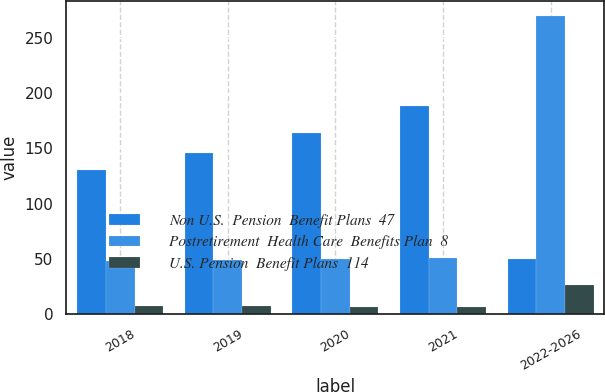Convert chart to OTSL. <chart><loc_0><loc_0><loc_500><loc_500><stacked_bar_chart><ecel><fcel>2018<fcel>2019<fcel>2020<fcel>2021<fcel>2022-2026<nl><fcel>Non U.S.  Pension  Benefit Plans  47<fcel>130<fcel>146<fcel>164<fcel>188<fcel>49.5<nl><fcel>Postretirement  Health Care  Benefits Plan  8<fcel>48<fcel>49<fcel>50<fcel>51<fcel>270<nl><fcel>U.S. Pension  Benefit Plans  114<fcel>7<fcel>7<fcel>6<fcel>6<fcel>26<nl></chart> 